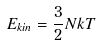Convert formula to latex. <formula><loc_0><loc_0><loc_500><loc_500>E _ { k i n } = \frac { 3 } { 2 } N k T</formula> 